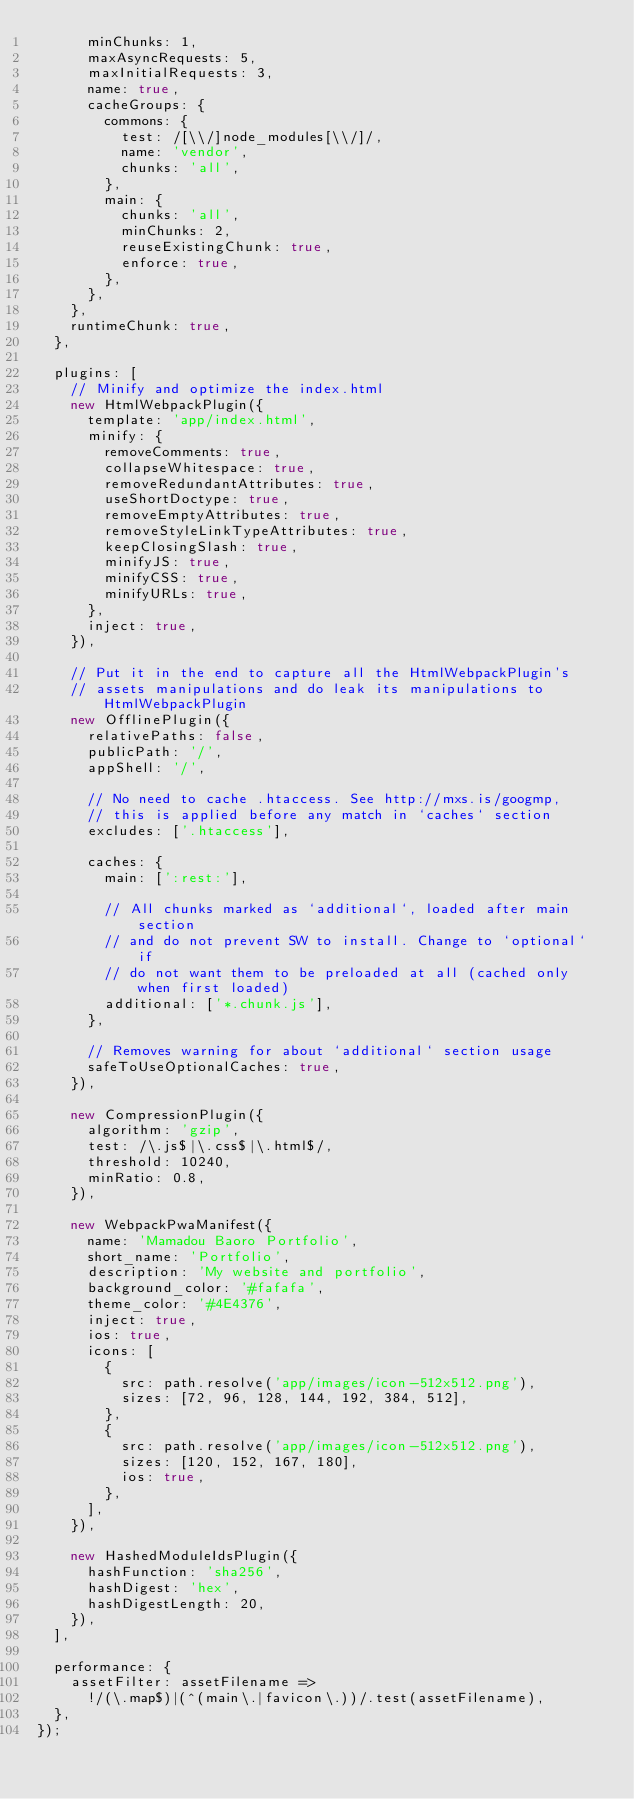Convert code to text. <code><loc_0><loc_0><loc_500><loc_500><_JavaScript_>      minChunks: 1,
      maxAsyncRequests: 5,
      maxInitialRequests: 3,
      name: true,
      cacheGroups: {
        commons: {
          test: /[\\/]node_modules[\\/]/,
          name: 'vendor',
          chunks: 'all',
        },
        main: {
          chunks: 'all',
          minChunks: 2,
          reuseExistingChunk: true,
          enforce: true,
        },
      },
    },
    runtimeChunk: true,
  },

  plugins: [
    // Minify and optimize the index.html
    new HtmlWebpackPlugin({
      template: 'app/index.html',
      minify: {
        removeComments: true,
        collapseWhitespace: true,
        removeRedundantAttributes: true,
        useShortDoctype: true,
        removeEmptyAttributes: true,
        removeStyleLinkTypeAttributes: true,
        keepClosingSlash: true,
        minifyJS: true,
        minifyCSS: true,
        minifyURLs: true,
      },
      inject: true,
    }),

    // Put it in the end to capture all the HtmlWebpackPlugin's
    // assets manipulations and do leak its manipulations to HtmlWebpackPlugin
    new OfflinePlugin({
      relativePaths: false,
      publicPath: '/',
      appShell: '/',

      // No need to cache .htaccess. See http://mxs.is/googmp,
      // this is applied before any match in `caches` section
      excludes: ['.htaccess'],

      caches: {
        main: [':rest:'],

        // All chunks marked as `additional`, loaded after main section
        // and do not prevent SW to install. Change to `optional` if
        // do not want them to be preloaded at all (cached only when first loaded)
        additional: ['*.chunk.js'],
      },

      // Removes warning for about `additional` section usage
      safeToUseOptionalCaches: true,
    }),

    new CompressionPlugin({
      algorithm: 'gzip',
      test: /\.js$|\.css$|\.html$/,
      threshold: 10240,
      minRatio: 0.8,
    }),

    new WebpackPwaManifest({
      name: 'Mamadou Baoro Portfolio',
      short_name: 'Portfolio',
      description: 'My website and portfolio',
      background_color: '#fafafa',
      theme_color: '#4E4376',
      inject: true,
      ios: true,
      icons: [
        {
          src: path.resolve('app/images/icon-512x512.png'),
          sizes: [72, 96, 128, 144, 192, 384, 512],
        },
        {
          src: path.resolve('app/images/icon-512x512.png'),
          sizes: [120, 152, 167, 180],
          ios: true,
        },
      ],
    }),

    new HashedModuleIdsPlugin({
      hashFunction: 'sha256',
      hashDigest: 'hex',
      hashDigestLength: 20,
    }),
  ],

  performance: {
    assetFilter: assetFilename =>
      !/(\.map$)|(^(main\.|favicon\.))/.test(assetFilename),
  },
});
</code> 